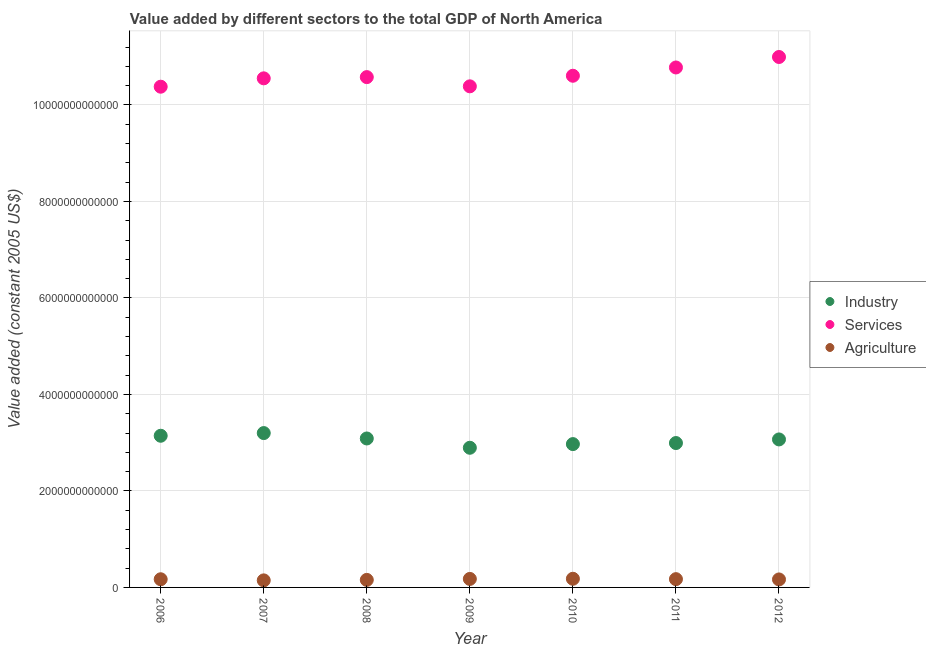What is the value added by agricultural sector in 2012?
Offer a terse response. 1.66e+11. Across all years, what is the maximum value added by agricultural sector?
Give a very brief answer. 1.79e+11. Across all years, what is the minimum value added by industrial sector?
Your response must be concise. 2.89e+12. In which year was the value added by industrial sector maximum?
Offer a terse response. 2007. What is the total value added by industrial sector in the graph?
Your response must be concise. 2.14e+13. What is the difference between the value added by services in 2010 and that in 2012?
Offer a terse response. -3.89e+11. What is the difference between the value added by services in 2011 and the value added by agricultural sector in 2006?
Your answer should be very brief. 1.06e+13. What is the average value added by industrial sector per year?
Keep it short and to the point. 3.05e+12. In the year 2007, what is the difference between the value added by services and value added by agricultural sector?
Give a very brief answer. 1.04e+13. What is the ratio of the value added by industrial sector in 2008 to that in 2009?
Offer a terse response. 1.07. What is the difference between the highest and the second highest value added by industrial sector?
Ensure brevity in your answer.  5.56e+1. What is the difference between the highest and the lowest value added by agricultural sector?
Give a very brief answer. 3.33e+1. In how many years, is the value added by services greater than the average value added by services taken over all years?
Offer a terse response. 2. Is the sum of the value added by services in 2006 and 2009 greater than the maximum value added by agricultural sector across all years?
Your response must be concise. Yes. What is the difference between two consecutive major ticks on the Y-axis?
Keep it short and to the point. 2.00e+12. Does the graph contain any zero values?
Provide a short and direct response. No. Where does the legend appear in the graph?
Make the answer very short. Center right. How many legend labels are there?
Ensure brevity in your answer.  3. How are the legend labels stacked?
Give a very brief answer. Vertical. What is the title of the graph?
Your answer should be compact. Value added by different sectors to the total GDP of North America. Does "Central government" appear as one of the legend labels in the graph?
Ensure brevity in your answer.  No. What is the label or title of the X-axis?
Keep it short and to the point. Year. What is the label or title of the Y-axis?
Provide a short and direct response. Value added (constant 2005 US$). What is the Value added (constant 2005 US$) of Industry in 2006?
Your response must be concise. 3.14e+12. What is the Value added (constant 2005 US$) in Services in 2006?
Your response must be concise. 1.04e+13. What is the Value added (constant 2005 US$) of Agriculture in 2006?
Your answer should be very brief. 1.69e+11. What is the Value added (constant 2005 US$) in Industry in 2007?
Offer a terse response. 3.20e+12. What is the Value added (constant 2005 US$) of Services in 2007?
Provide a short and direct response. 1.06e+13. What is the Value added (constant 2005 US$) of Agriculture in 2007?
Provide a short and direct response. 1.46e+11. What is the Value added (constant 2005 US$) of Industry in 2008?
Your response must be concise. 3.09e+12. What is the Value added (constant 2005 US$) in Services in 2008?
Provide a succinct answer. 1.06e+13. What is the Value added (constant 2005 US$) in Agriculture in 2008?
Give a very brief answer. 1.56e+11. What is the Value added (constant 2005 US$) of Industry in 2009?
Make the answer very short. 2.89e+12. What is the Value added (constant 2005 US$) in Services in 2009?
Give a very brief answer. 1.04e+13. What is the Value added (constant 2005 US$) in Agriculture in 2009?
Keep it short and to the point. 1.76e+11. What is the Value added (constant 2005 US$) of Industry in 2010?
Make the answer very short. 2.97e+12. What is the Value added (constant 2005 US$) in Services in 2010?
Provide a short and direct response. 1.06e+13. What is the Value added (constant 2005 US$) in Agriculture in 2010?
Give a very brief answer. 1.79e+11. What is the Value added (constant 2005 US$) in Industry in 2011?
Your response must be concise. 2.99e+12. What is the Value added (constant 2005 US$) of Services in 2011?
Keep it short and to the point. 1.08e+13. What is the Value added (constant 2005 US$) of Agriculture in 2011?
Keep it short and to the point. 1.71e+11. What is the Value added (constant 2005 US$) in Industry in 2012?
Give a very brief answer. 3.07e+12. What is the Value added (constant 2005 US$) of Services in 2012?
Give a very brief answer. 1.10e+13. What is the Value added (constant 2005 US$) of Agriculture in 2012?
Offer a very short reply. 1.66e+11. Across all years, what is the maximum Value added (constant 2005 US$) in Industry?
Give a very brief answer. 3.20e+12. Across all years, what is the maximum Value added (constant 2005 US$) of Services?
Offer a terse response. 1.10e+13. Across all years, what is the maximum Value added (constant 2005 US$) in Agriculture?
Keep it short and to the point. 1.79e+11. Across all years, what is the minimum Value added (constant 2005 US$) in Industry?
Your answer should be compact. 2.89e+12. Across all years, what is the minimum Value added (constant 2005 US$) in Services?
Your answer should be very brief. 1.04e+13. Across all years, what is the minimum Value added (constant 2005 US$) in Agriculture?
Make the answer very short. 1.46e+11. What is the total Value added (constant 2005 US$) of Industry in the graph?
Provide a succinct answer. 2.14e+13. What is the total Value added (constant 2005 US$) in Services in the graph?
Offer a very short reply. 7.43e+13. What is the total Value added (constant 2005 US$) of Agriculture in the graph?
Offer a very short reply. 1.16e+12. What is the difference between the Value added (constant 2005 US$) in Industry in 2006 and that in 2007?
Give a very brief answer. -5.56e+1. What is the difference between the Value added (constant 2005 US$) in Services in 2006 and that in 2007?
Provide a short and direct response. -1.73e+11. What is the difference between the Value added (constant 2005 US$) in Agriculture in 2006 and that in 2007?
Provide a succinct answer. 2.32e+1. What is the difference between the Value added (constant 2005 US$) of Industry in 2006 and that in 2008?
Your answer should be compact. 5.63e+1. What is the difference between the Value added (constant 2005 US$) of Services in 2006 and that in 2008?
Your answer should be very brief. -1.99e+11. What is the difference between the Value added (constant 2005 US$) in Agriculture in 2006 and that in 2008?
Your response must be concise. 1.33e+1. What is the difference between the Value added (constant 2005 US$) in Industry in 2006 and that in 2009?
Offer a terse response. 2.49e+11. What is the difference between the Value added (constant 2005 US$) in Services in 2006 and that in 2009?
Offer a terse response. -7.72e+09. What is the difference between the Value added (constant 2005 US$) in Agriculture in 2006 and that in 2009?
Keep it short and to the point. -6.85e+09. What is the difference between the Value added (constant 2005 US$) of Industry in 2006 and that in 2010?
Offer a very short reply. 1.73e+11. What is the difference between the Value added (constant 2005 US$) in Services in 2006 and that in 2010?
Make the answer very short. -2.27e+11. What is the difference between the Value added (constant 2005 US$) in Agriculture in 2006 and that in 2010?
Provide a short and direct response. -1.01e+1. What is the difference between the Value added (constant 2005 US$) of Industry in 2006 and that in 2011?
Offer a terse response. 1.51e+11. What is the difference between the Value added (constant 2005 US$) of Services in 2006 and that in 2011?
Keep it short and to the point. -3.99e+11. What is the difference between the Value added (constant 2005 US$) of Agriculture in 2006 and that in 2011?
Your answer should be very brief. -2.07e+09. What is the difference between the Value added (constant 2005 US$) of Industry in 2006 and that in 2012?
Your answer should be compact. 7.61e+1. What is the difference between the Value added (constant 2005 US$) in Services in 2006 and that in 2012?
Provide a succinct answer. -6.16e+11. What is the difference between the Value added (constant 2005 US$) in Agriculture in 2006 and that in 2012?
Give a very brief answer. 3.76e+09. What is the difference between the Value added (constant 2005 US$) in Industry in 2007 and that in 2008?
Make the answer very short. 1.12e+11. What is the difference between the Value added (constant 2005 US$) of Services in 2007 and that in 2008?
Your response must be concise. -2.54e+1. What is the difference between the Value added (constant 2005 US$) in Agriculture in 2007 and that in 2008?
Offer a terse response. -9.92e+09. What is the difference between the Value added (constant 2005 US$) of Industry in 2007 and that in 2009?
Your response must be concise. 3.05e+11. What is the difference between the Value added (constant 2005 US$) of Services in 2007 and that in 2009?
Provide a short and direct response. 1.66e+11. What is the difference between the Value added (constant 2005 US$) in Agriculture in 2007 and that in 2009?
Keep it short and to the point. -3.01e+1. What is the difference between the Value added (constant 2005 US$) of Industry in 2007 and that in 2010?
Your answer should be compact. 2.28e+11. What is the difference between the Value added (constant 2005 US$) in Services in 2007 and that in 2010?
Provide a succinct answer. -5.35e+1. What is the difference between the Value added (constant 2005 US$) of Agriculture in 2007 and that in 2010?
Give a very brief answer. -3.33e+1. What is the difference between the Value added (constant 2005 US$) of Industry in 2007 and that in 2011?
Make the answer very short. 2.07e+11. What is the difference between the Value added (constant 2005 US$) of Services in 2007 and that in 2011?
Your response must be concise. -2.25e+11. What is the difference between the Value added (constant 2005 US$) in Agriculture in 2007 and that in 2011?
Provide a succinct answer. -2.53e+1. What is the difference between the Value added (constant 2005 US$) of Industry in 2007 and that in 2012?
Your answer should be very brief. 1.32e+11. What is the difference between the Value added (constant 2005 US$) of Services in 2007 and that in 2012?
Ensure brevity in your answer.  -4.42e+11. What is the difference between the Value added (constant 2005 US$) of Agriculture in 2007 and that in 2012?
Make the answer very short. -1.95e+1. What is the difference between the Value added (constant 2005 US$) in Industry in 2008 and that in 2009?
Provide a succinct answer. 1.93e+11. What is the difference between the Value added (constant 2005 US$) in Services in 2008 and that in 2009?
Offer a very short reply. 1.91e+11. What is the difference between the Value added (constant 2005 US$) of Agriculture in 2008 and that in 2009?
Offer a very short reply. -2.01e+1. What is the difference between the Value added (constant 2005 US$) of Industry in 2008 and that in 2010?
Your answer should be very brief. 1.17e+11. What is the difference between the Value added (constant 2005 US$) in Services in 2008 and that in 2010?
Your response must be concise. -2.81e+1. What is the difference between the Value added (constant 2005 US$) of Agriculture in 2008 and that in 2010?
Offer a very short reply. -2.34e+1. What is the difference between the Value added (constant 2005 US$) in Industry in 2008 and that in 2011?
Make the answer very short. 9.47e+1. What is the difference between the Value added (constant 2005 US$) in Services in 2008 and that in 2011?
Give a very brief answer. -2.00e+11. What is the difference between the Value added (constant 2005 US$) of Agriculture in 2008 and that in 2011?
Ensure brevity in your answer.  -1.54e+1. What is the difference between the Value added (constant 2005 US$) in Industry in 2008 and that in 2012?
Your answer should be compact. 1.98e+1. What is the difference between the Value added (constant 2005 US$) in Services in 2008 and that in 2012?
Give a very brief answer. -4.17e+11. What is the difference between the Value added (constant 2005 US$) in Agriculture in 2008 and that in 2012?
Give a very brief answer. -9.54e+09. What is the difference between the Value added (constant 2005 US$) in Industry in 2009 and that in 2010?
Keep it short and to the point. -7.61e+1. What is the difference between the Value added (constant 2005 US$) in Services in 2009 and that in 2010?
Your answer should be very brief. -2.19e+11. What is the difference between the Value added (constant 2005 US$) of Agriculture in 2009 and that in 2010?
Your answer should be very brief. -3.25e+09. What is the difference between the Value added (constant 2005 US$) of Industry in 2009 and that in 2011?
Your response must be concise. -9.79e+1. What is the difference between the Value added (constant 2005 US$) of Services in 2009 and that in 2011?
Ensure brevity in your answer.  -3.91e+11. What is the difference between the Value added (constant 2005 US$) in Agriculture in 2009 and that in 2011?
Make the answer very short. 4.78e+09. What is the difference between the Value added (constant 2005 US$) in Industry in 2009 and that in 2012?
Your answer should be compact. -1.73e+11. What is the difference between the Value added (constant 2005 US$) in Services in 2009 and that in 2012?
Ensure brevity in your answer.  -6.08e+11. What is the difference between the Value added (constant 2005 US$) of Agriculture in 2009 and that in 2012?
Offer a terse response. 1.06e+1. What is the difference between the Value added (constant 2005 US$) in Industry in 2010 and that in 2011?
Your response must be concise. -2.18e+1. What is the difference between the Value added (constant 2005 US$) of Services in 2010 and that in 2011?
Your response must be concise. -1.72e+11. What is the difference between the Value added (constant 2005 US$) in Agriculture in 2010 and that in 2011?
Offer a very short reply. 8.03e+09. What is the difference between the Value added (constant 2005 US$) of Industry in 2010 and that in 2012?
Keep it short and to the point. -9.67e+1. What is the difference between the Value added (constant 2005 US$) in Services in 2010 and that in 2012?
Provide a short and direct response. -3.89e+11. What is the difference between the Value added (constant 2005 US$) of Agriculture in 2010 and that in 2012?
Provide a short and direct response. 1.39e+1. What is the difference between the Value added (constant 2005 US$) in Industry in 2011 and that in 2012?
Offer a very short reply. -7.49e+1. What is the difference between the Value added (constant 2005 US$) of Services in 2011 and that in 2012?
Your answer should be compact. -2.17e+11. What is the difference between the Value added (constant 2005 US$) of Agriculture in 2011 and that in 2012?
Offer a very short reply. 5.82e+09. What is the difference between the Value added (constant 2005 US$) of Industry in 2006 and the Value added (constant 2005 US$) of Services in 2007?
Make the answer very short. -7.41e+12. What is the difference between the Value added (constant 2005 US$) of Industry in 2006 and the Value added (constant 2005 US$) of Agriculture in 2007?
Provide a succinct answer. 3.00e+12. What is the difference between the Value added (constant 2005 US$) in Services in 2006 and the Value added (constant 2005 US$) in Agriculture in 2007?
Your answer should be very brief. 1.02e+13. What is the difference between the Value added (constant 2005 US$) of Industry in 2006 and the Value added (constant 2005 US$) of Services in 2008?
Your response must be concise. -7.43e+12. What is the difference between the Value added (constant 2005 US$) in Industry in 2006 and the Value added (constant 2005 US$) in Agriculture in 2008?
Make the answer very short. 2.99e+12. What is the difference between the Value added (constant 2005 US$) in Services in 2006 and the Value added (constant 2005 US$) in Agriculture in 2008?
Your answer should be compact. 1.02e+13. What is the difference between the Value added (constant 2005 US$) in Industry in 2006 and the Value added (constant 2005 US$) in Services in 2009?
Provide a succinct answer. -7.24e+12. What is the difference between the Value added (constant 2005 US$) of Industry in 2006 and the Value added (constant 2005 US$) of Agriculture in 2009?
Offer a terse response. 2.97e+12. What is the difference between the Value added (constant 2005 US$) in Services in 2006 and the Value added (constant 2005 US$) in Agriculture in 2009?
Provide a short and direct response. 1.02e+13. What is the difference between the Value added (constant 2005 US$) in Industry in 2006 and the Value added (constant 2005 US$) in Services in 2010?
Provide a succinct answer. -7.46e+12. What is the difference between the Value added (constant 2005 US$) in Industry in 2006 and the Value added (constant 2005 US$) in Agriculture in 2010?
Provide a short and direct response. 2.96e+12. What is the difference between the Value added (constant 2005 US$) of Services in 2006 and the Value added (constant 2005 US$) of Agriculture in 2010?
Your answer should be very brief. 1.02e+13. What is the difference between the Value added (constant 2005 US$) of Industry in 2006 and the Value added (constant 2005 US$) of Services in 2011?
Your response must be concise. -7.63e+12. What is the difference between the Value added (constant 2005 US$) of Industry in 2006 and the Value added (constant 2005 US$) of Agriculture in 2011?
Offer a terse response. 2.97e+12. What is the difference between the Value added (constant 2005 US$) of Services in 2006 and the Value added (constant 2005 US$) of Agriculture in 2011?
Give a very brief answer. 1.02e+13. What is the difference between the Value added (constant 2005 US$) of Industry in 2006 and the Value added (constant 2005 US$) of Services in 2012?
Offer a very short reply. -7.85e+12. What is the difference between the Value added (constant 2005 US$) of Industry in 2006 and the Value added (constant 2005 US$) of Agriculture in 2012?
Provide a short and direct response. 2.98e+12. What is the difference between the Value added (constant 2005 US$) in Services in 2006 and the Value added (constant 2005 US$) in Agriculture in 2012?
Offer a very short reply. 1.02e+13. What is the difference between the Value added (constant 2005 US$) of Industry in 2007 and the Value added (constant 2005 US$) of Services in 2008?
Provide a short and direct response. -7.38e+12. What is the difference between the Value added (constant 2005 US$) of Industry in 2007 and the Value added (constant 2005 US$) of Agriculture in 2008?
Ensure brevity in your answer.  3.04e+12. What is the difference between the Value added (constant 2005 US$) of Services in 2007 and the Value added (constant 2005 US$) of Agriculture in 2008?
Keep it short and to the point. 1.04e+13. What is the difference between the Value added (constant 2005 US$) in Industry in 2007 and the Value added (constant 2005 US$) in Services in 2009?
Provide a short and direct response. -7.19e+12. What is the difference between the Value added (constant 2005 US$) in Industry in 2007 and the Value added (constant 2005 US$) in Agriculture in 2009?
Make the answer very short. 3.02e+12. What is the difference between the Value added (constant 2005 US$) in Services in 2007 and the Value added (constant 2005 US$) in Agriculture in 2009?
Your answer should be very brief. 1.04e+13. What is the difference between the Value added (constant 2005 US$) of Industry in 2007 and the Value added (constant 2005 US$) of Services in 2010?
Give a very brief answer. -7.41e+12. What is the difference between the Value added (constant 2005 US$) of Industry in 2007 and the Value added (constant 2005 US$) of Agriculture in 2010?
Provide a succinct answer. 3.02e+12. What is the difference between the Value added (constant 2005 US$) of Services in 2007 and the Value added (constant 2005 US$) of Agriculture in 2010?
Make the answer very short. 1.04e+13. What is the difference between the Value added (constant 2005 US$) in Industry in 2007 and the Value added (constant 2005 US$) in Services in 2011?
Give a very brief answer. -7.58e+12. What is the difference between the Value added (constant 2005 US$) of Industry in 2007 and the Value added (constant 2005 US$) of Agriculture in 2011?
Provide a succinct answer. 3.03e+12. What is the difference between the Value added (constant 2005 US$) in Services in 2007 and the Value added (constant 2005 US$) in Agriculture in 2011?
Give a very brief answer. 1.04e+13. What is the difference between the Value added (constant 2005 US$) in Industry in 2007 and the Value added (constant 2005 US$) in Services in 2012?
Ensure brevity in your answer.  -7.80e+12. What is the difference between the Value added (constant 2005 US$) of Industry in 2007 and the Value added (constant 2005 US$) of Agriculture in 2012?
Provide a succinct answer. 3.03e+12. What is the difference between the Value added (constant 2005 US$) in Services in 2007 and the Value added (constant 2005 US$) in Agriculture in 2012?
Your answer should be compact. 1.04e+13. What is the difference between the Value added (constant 2005 US$) in Industry in 2008 and the Value added (constant 2005 US$) in Services in 2009?
Offer a very short reply. -7.30e+12. What is the difference between the Value added (constant 2005 US$) of Industry in 2008 and the Value added (constant 2005 US$) of Agriculture in 2009?
Make the answer very short. 2.91e+12. What is the difference between the Value added (constant 2005 US$) in Services in 2008 and the Value added (constant 2005 US$) in Agriculture in 2009?
Offer a very short reply. 1.04e+13. What is the difference between the Value added (constant 2005 US$) in Industry in 2008 and the Value added (constant 2005 US$) in Services in 2010?
Provide a short and direct response. -7.52e+12. What is the difference between the Value added (constant 2005 US$) in Industry in 2008 and the Value added (constant 2005 US$) in Agriculture in 2010?
Offer a very short reply. 2.91e+12. What is the difference between the Value added (constant 2005 US$) of Services in 2008 and the Value added (constant 2005 US$) of Agriculture in 2010?
Keep it short and to the point. 1.04e+13. What is the difference between the Value added (constant 2005 US$) of Industry in 2008 and the Value added (constant 2005 US$) of Services in 2011?
Make the answer very short. -7.69e+12. What is the difference between the Value added (constant 2005 US$) in Industry in 2008 and the Value added (constant 2005 US$) in Agriculture in 2011?
Your response must be concise. 2.92e+12. What is the difference between the Value added (constant 2005 US$) of Services in 2008 and the Value added (constant 2005 US$) of Agriculture in 2011?
Keep it short and to the point. 1.04e+13. What is the difference between the Value added (constant 2005 US$) of Industry in 2008 and the Value added (constant 2005 US$) of Services in 2012?
Provide a short and direct response. -7.91e+12. What is the difference between the Value added (constant 2005 US$) in Industry in 2008 and the Value added (constant 2005 US$) in Agriculture in 2012?
Your answer should be compact. 2.92e+12. What is the difference between the Value added (constant 2005 US$) in Services in 2008 and the Value added (constant 2005 US$) in Agriculture in 2012?
Make the answer very short. 1.04e+13. What is the difference between the Value added (constant 2005 US$) of Industry in 2009 and the Value added (constant 2005 US$) of Services in 2010?
Provide a short and direct response. -7.71e+12. What is the difference between the Value added (constant 2005 US$) of Industry in 2009 and the Value added (constant 2005 US$) of Agriculture in 2010?
Your answer should be very brief. 2.72e+12. What is the difference between the Value added (constant 2005 US$) of Services in 2009 and the Value added (constant 2005 US$) of Agriculture in 2010?
Provide a short and direct response. 1.02e+13. What is the difference between the Value added (constant 2005 US$) of Industry in 2009 and the Value added (constant 2005 US$) of Services in 2011?
Provide a short and direct response. -7.88e+12. What is the difference between the Value added (constant 2005 US$) in Industry in 2009 and the Value added (constant 2005 US$) in Agriculture in 2011?
Your answer should be compact. 2.72e+12. What is the difference between the Value added (constant 2005 US$) of Services in 2009 and the Value added (constant 2005 US$) of Agriculture in 2011?
Offer a terse response. 1.02e+13. What is the difference between the Value added (constant 2005 US$) in Industry in 2009 and the Value added (constant 2005 US$) in Services in 2012?
Your response must be concise. -8.10e+12. What is the difference between the Value added (constant 2005 US$) of Industry in 2009 and the Value added (constant 2005 US$) of Agriculture in 2012?
Offer a very short reply. 2.73e+12. What is the difference between the Value added (constant 2005 US$) of Services in 2009 and the Value added (constant 2005 US$) of Agriculture in 2012?
Make the answer very short. 1.02e+13. What is the difference between the Value added (constant 2005 US$) of Industry in 2010 and the Value added (constant 2005 US$) of Services in 2011?
Provide a short and direct response. -7.81e+12. What is the difference between the Value added (constant 2005 US$) of Industry in 2010 and the Value added (constant 2005 US$) of Agriculture in 2011?
Provide a short and direct response. 2.80e+12. What is the difference between the Value added (constant 2005 US$) of Services in 2010 and the Value added (constant 2005 US$) of Agriculture in 2011?
Offer a very short reply. 1.04e+13. What is the difference between the Value added (constant 2005 US$) in Industry in 2010 and the Value added (constant 2005 US$) in Services in 2012?
Make the answer very short. -8.02e+12. What is the difference between the Value added (constant 2005 US$) in Industry in 2010 and the Value added (constant 2005 US$) in Agriculture in 2012?
Keep it short and to the point. 2.81e+12. What is the difference between the Value added (constant 2005 US$) of Services in 2010 and the Value added (constant 2005 US$) of Agriculture in 2012?
Give a very brief answer. 1.04e+13. What is the difference between the Value added (constant 2005 US$) of Industry in 2011 and the Value added (constant 2005 US$) of Services in 2012?
Provide a short and direct response. -8.00e+12. What is the difference between the Value added (constant 2005 US$) of Industry in 2011 and the Value added (constant 2005 US$) of Agriculture in 2012?
Your response must be concise. 2.83e+12. What is the difference between the Value added (constant 2005 US$) in Services in 2011 and the Value added (constant 2005 US$) in Agriculture in 2012?
Keep it short and to the point. 1.06e+13. What is the average Value added (constant 2005 US$) in Industry per year?
Offer a very short reply. 3.05e+12. What is the average Value added (constant 2005 US$) in Services per year?
Your answer should be compact. 1.06e+13. What is the average Value added (constant 2005 US$) of Agriculture per year?
Keep it short and to the point. 1.66e+11. In the year 2006, what is the difference between the Value added (constant 2005 US$) in Industry and Value added (constant 2005 US$) in Services?
Provide a succinct answer. -7.24e+12. In the year 2006, what is the difference between the Value added (constant 2005 US$) of Industry and Value added (constant 2005 US$) of Agriculture?
Keep it short and to the point. 2.97e+12. In the year 2006, what is the difference between the Value added (constant 2005 US$) in Services and Value added (constant 2005 US$) in Agriculture?
Keep it short and to the point. 1.02e+13. In the year 2007, what is the difference between the Value added (constant 2005 US$) in Industry and Value added (constant 2005 US$) in Services?
Your answer should be compact. -7.35e+12. In the year 2007, what is the difference between the Value added (constant 2005 US$) of Industry and Value added (constant 2005 US$) of Agriculture?
Offer a very short reply. 3.05e+12. In the year 2007, what is the difference between the Value added (constant 2005 US$) in Services and Value added (constant 2005 US$) in Agriculture?
Your answer should be compact. 1.04e+13. In the year 2008, what is the difference between the Value added (constant 2005 US$) in Industry and Value added (constant 2005 US$) in Services?
Offer a terse response. -7.49e+12. In the year 2008, what is the difference between the Value added (constant 2005 US$) in Industry and Value added (constant 2005 US$) in Agriculture?
Keep it short and to the point. 2.93e+12. In the year 2008, what is the difference between the Value added (constant 2005 US$) of Services and Value added (constant 2005 US$) of Agriculture?
Your answer should be compact. 1.04e+13. In the year 2009, what is the difference between the Value added (constant 2005 US$) in Industry and Value added (constant 2005 US$) in Services?
Give a very brief answer. -7.49e+12. In the year 2009, what is the difference between the Value added (constant 2005 US$) in Industry and Value added (constant 2005 US$) in Agriculture?
Give a very brief answer. 2.72e+12. In the year 2009, what is the difference between the Value added (constant 2005 US$) of Services and Value added (constant 2005 US$) of Agriculture?
Provide a short and direct response. 1.02e+13. In the year 2010, what is the difference between the Value added (constant 2005 US$) in Industry and Value added (constant 2005 US$) in Services?
Make the answer very short. -7.63e+12. In the year 2010, what is the difference between the Value added (constant 2005 US$) in Industry and Value added (constant 2005 US$) in Agriculture?
Your response must be concise. 2.79e+12. In the year 2010, what is the difference between the Value added (constant 2005 US$) of Services and Value added (constant 2005 US$) of Agriculture?
Your answer should be compact. 1.04e+13. In the year 2011, what is the difference between the Value added (constant 2005 US$) in Industry and Value added (constant 2005 US$) in Services?
Make the answer very short. -7.78e+12. In the year 2011, what is the difference between the Value added (constant 2005 US$) of Industry and Value added (constant 2005 US$) of Agriculture?
Give a very brief answer. 2.82e+12. In the year 2011, what is the difference between the Value added (constant 2005 US$) of Services and Value added (constant 2005 US$) of Agriculture?
Offer a terse response. 1.06e+13. In the year 2012, what is the difference between the Value added (constant 2005 US$) of Industry and Value added (constant 2005 US$) of Services?
Your answer should be compact. -7.93e+12. In the year 2012, what is the difference between the Value added (constant 2005 US$) of Industry and Value added (constant 2005 US$) of Agriculture?
Ensure brevity in your answer.  2.90e+12. In the year 2012, what is the difference between the Value added (constant 2005 US$) of Services and Value added (constant 2005 US$) of Agriculture?
Offer a terse response. 1.08e+13. What is the ratio of the Value added (constant 2005 US$) of Industry in 2006 to that in 2007?
Your answer should be compact. 0.98. What is the ratio of the Value added (constant 2005 US$) in Services in 2006 to that in 2007?
Provide a succinct answer. 0.98. What is the ratio of the Value added (constant 2005 US$) of Agriculture in 2006 to that in 2007?
Ensure brevity in your answer.  1.16. What is the ratio of the Value added (constant 2005 US$) in Industry in 2006 to that in 2008?
Your answer should be very brief. 1.02. What is the ratio of the Value added (constant 2005 US$) in Services in 2006 to that in 2008?
Ensure brevity in your answer.  0.98. What is the ratio of the Value added (constant 2005 US$) in Agriculture in 2006 to that in 2008?
Give a very brief answer. 1.09. What is the ratio of the Value added (constant 2005 US$) of Industry in 2006 to that in 2009?
Offer a very short reply. 1.09. What is the ratio of the Value added (constant 2005 US$) in Services in 2006 to that in 2009?
Ensure brevity in your answer.  1. What is the ratio of the Value added (constant 2005 US$) of Agriculture in 2006 to that in 2009?
Your response must be concise. 0.96. What is the ratio of the Value added (constant 2005 US$) of Industry in 2006 to that in 2010?
Your answer should be compact. 1.06. What is the ratio of the Value added (constant 2005 US$) of Services in 2006 to that in 2010?
Your answer should be very brief. 0.98. What is the ratio of the Value added (constant 2005 US$) of Agriculture in 2006 to that in 2010?
Offer a very short reply. 0.94. What is the ratio of the Value added (constant 2005 US$) of Industry in 2006 to that in 2011?
Provide a short and direct response. 1.05. What is the ratio of the Value added (constant 2005 US$) in Services in 2006 to that in 2011?
Ensure brevity in your answer.  0.96. What is the ratio of the Value added (constant 2005 US$) of Agriculture in 2006 to that in 2011?
Offer a very short reply. 0.99. What is the ratio of the Value added (constant 2005 US$) in Industry in 2006 to that in 2012?
Keep it short and to the point. 1.02. What is the ratio of the Value added (constant 2005 US$) of Services in 2006 to that in 2012?
Offer a very short reply. 0.94. What is the ratio of the Value added (constant 2005 US$) of Agriculture in 2006 to that in 2012?
Provide a succinct answer. 1.02. What is the ratio of the Value added (constant 2005 US$) in Industry in 2007 to that in 2008?
Your answer should be very brief. 1.04. What is the ratio of the Value added (constant 2005 US$) of Services in 2007 to that in 2008?
Provide a short and direct response. 1. What is the ratio of the Value added (constant 2005 US$) in Agriculture in 2007 to that in 2008?
Ensure brevity in your answer.  0.94. What is the ratio of the Value added (constant 2005 US$) of Industry in 2007 to that in 2009?
Your response must be concise. 1.11. What is the ratio of the Value added (constant 2005 US$) in Services in 2007 to that in 2009?
Offer a very short reply. 1.02. What is the ratio of the Value added (constant 2005 US$) of Agriculture in 2007 to that in 2009?
Provide a succinct answer. 0.83. What is the ratio of the Value added (constant 2005 US$) in Services in 2007 to that in 2010?
Make the answer very short. 0.99. What is the ratio of the Value added (constant 2005 US$) of Agriculture in 2007 to that in 2010?
Ensure brevity in your answer.  0.81. What is the ratio of the Value added (constant 2005 US$) of Industry in 2007 to that in 2011?
Offer a terse response. 1.07. What is the ratio of the Value added (constant 2005 US$) of Services in 2007 to that in 2011?
Keep it short and to the point. 0.98. What is the ratio of the Value added (constant 2005 US$) of Agriculture in 2007 to that in 2011?
Offer a very short reply. 0.85. What is the ratio of the Value added (constant 2005 US$) of Industry in 2007 to that in 2012?
Provide a succinct answer. 1.04. What is the ratio of the Value added (constant 2005 US$) of Services in 2007 to that in 2012?
Your answer should be very brief. 0.96. What is the ratio of the Value added (constant 2005 US$) in Agriculture in 2007 to that in 2012?
Make the answer very short. 0.88. What is the ratio of the Value added (constant 2005 US$) of Industry in 2008 to that in 2009?
Your response must be concise. 1.07. What is the ratio of the Value added (constant 2005 US$) of Services in 2008 to that in 2009?
Offer a terse response. 1.02. What is the ratio of the Value added (constant 2005 US$) in Agriculture in 2008 to that in 2009?
Ensure brevity in your answer.  0.89. What is the ratio of the Value added (constant 2005 US$) in Industry in 2008 to that in 2010?
Give a very brief answer. 1.04. What is the ratio of the Value added (constant 2005 US$) in Agriculture in 2008 to that in 2010?
Offer a terse response. 0.87. What is the ratio of the Value added (constant 2005 US$) in Industry in 2008 to that in 2011?
Your response must be concise. 1.03. What is the ratio of the Value added (constant 2005 US$) of Services in 2008 to that in 2011?
Your response must be concise. 0.98. What is the ratio of the Value added (constant 2005 US$) of Agriculture in 2008 to that in 2011?
Provide a succinct answer. 0.91. What is the ratio of the Value added (constant 2005 US$) of Services in 2008 to that in 2012?
Give a very brief answer. 0.96. What is the ratio of the Value added (constant 2005 US$) in Agriculture in 2008 to that in 2012?
Ensure brevity in your answer.  0.94. What is the ratio of the Value added (constant 2005 US$) in Industry in 2009 to that in 2010?
Offer a very short reply. 0.97. What is the ratio of the Value added (constant 2005 US$) of Services in 2009 to that in 2010?
Ensure brevity in your answer.  0.98. What is the ratio of the Value added (constant 2005 US$) of Agriculture in 2009 to that in 2010?
Your answer should be very brief. 0.98. What is the ratio of the Value added (constant 2005 US$) of Industry in 2009 to that in 2011?
Give a very brief answer. 0.97. What is the ratio of the Value added (constant 2005 US$) in Services in 2009 to that in 2011?
Provide a succinct answer. 0.96. What is the ratio of the Value added (constant 2005 US$) of Agriculture in 2009 to that in 2011?
Offer a very short reply. 1.03. What is the ratio of the Value added (constant 2005 US$) of Industry in 2009 to that in 2012?
Your response must be concise. 0.94. What is the ratio of the Value added (constant 2005 US$) in Services in 2009 to that in 2012?
Offer a terse response. 0.94. What is the ratio of the Value added (constant 2005 US$) of Agriculture in 2009 to that in 2012?
Keep it short and to the point. 1.06. What is the ratio of the Value added (constant 2005 US$) of Industry in 2010 to that in 2011?
Provide a succinct answer. 0.99. What is the ratio of the Value added (constant 2005 US$) in Services in 2010 to that in 2011?
Ensure brevity in your answer.  0.98. What is the ratio of the Value added (constant 2005 US$) in Agriculture in 2010 to that in 2011?
Offer a very short reply. 1.05. What is the ratio of the Value added (constant 2005 US$) in Industry in 2010 to that in 2012?
Keep it short and to the point. 0.97. What is the ratio of the Value added (constant 2005 US$) of Services in 2010 to that in 2012?
Provide a short and direct response. 0.96. What is the ratio of the Value added (constant 2005 US$) of Agriculture in 2010 to that in 2012?
Offer a terse response. 1.08. What is the ratio of the Value added (constant 2005 US$) in Industry in 2011 to that in 2012?
Offer a terse response. 0.98. What is the ratio of the Value added (constant 2005 US$) in Services in 2011 to that in 2012?
Your response must be concise. 0.98. What is the ratio of the Value added (constant 2005 US$) in Agriculture in 2011 to that in 2012?
Make the answer very short. 1.04. What is the difference between the highest and the second highest Value added (constant 2005 US$) in Industry?
Offer a terse response. 5.56e+1. What is the difference between the highest and the second highest Value added (constant 2005 US$) in Services?
Keep it short and to the point. 2.17e+11. What is the difference between the highest and the second highest Value added (constant 2005 US$) of Agriculture?
Your response must be concise. 3.25e+09. What is the difference between the highest and the lowest Value added (constant 2005 US$) in Industry?
Provide a short and direct response. 3.05e+11. What is the difference between the highest and the lowest Value added (constant 2005 US$) in Services?
Your response must be concise. 6.16e+11. What is the difference between the highest and the lowest Value added (constant 2005 US$) in Agriculture?
Your answer should be very brief. 3.33e+1. 